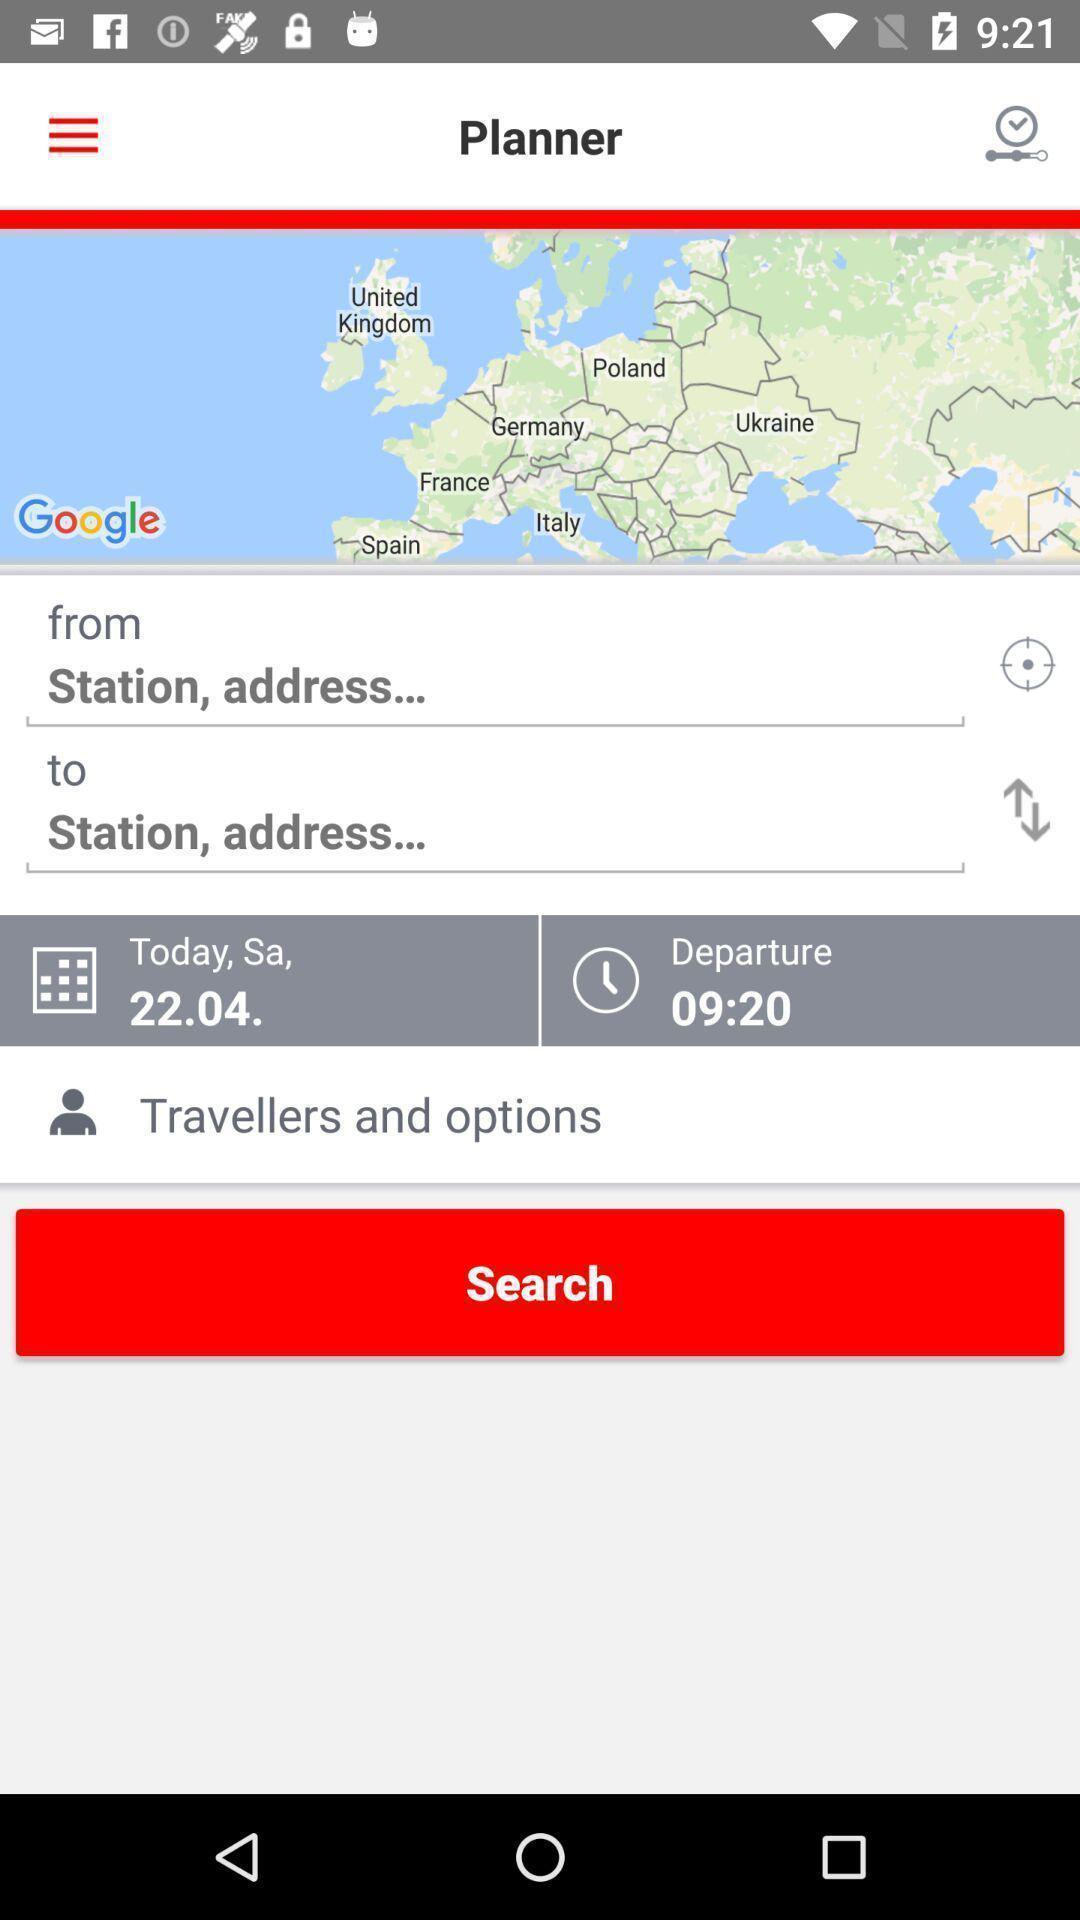Tell me about the visual elements in this screen capture. Search button to find location information in travelling app. 